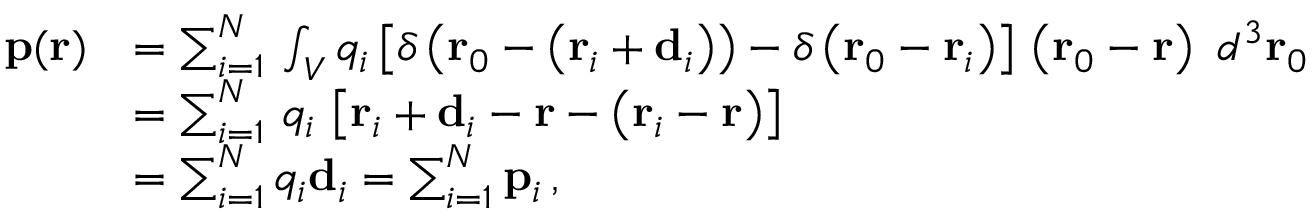<formula> <loc_0><loc_0><loc_500><loc_500>{ \begin{array} { r l } { p ( r ) } & { = \sum _ { i = 1 } ^ { N } \, \int _ { V } q _ { i } \left [ \delta \left ( r _ { 0 } - \left ( r _ { i } + d _ { i } \right ) \right ) - \delta \left ( r _ { 0 } - r _ { i } \right ) \right ] \, \left ( r _ { 0 } - r \right ) \ d ^ { 3 } r _ { 0 } } \\ & { = \sum _ { i = 1 } ^ { N } \, q _ { i } \, \left [ r _ { i } + d _ { i } - r - \left ( r _ { i } - r \right ) \right ] } \\ & { = \sum _ { i = 1 } ^ { N } q _ { i } d _ { i } = \sum _ { i = 1 } ^ { N } p _ { i } \, , } \end{array} }</formula> 